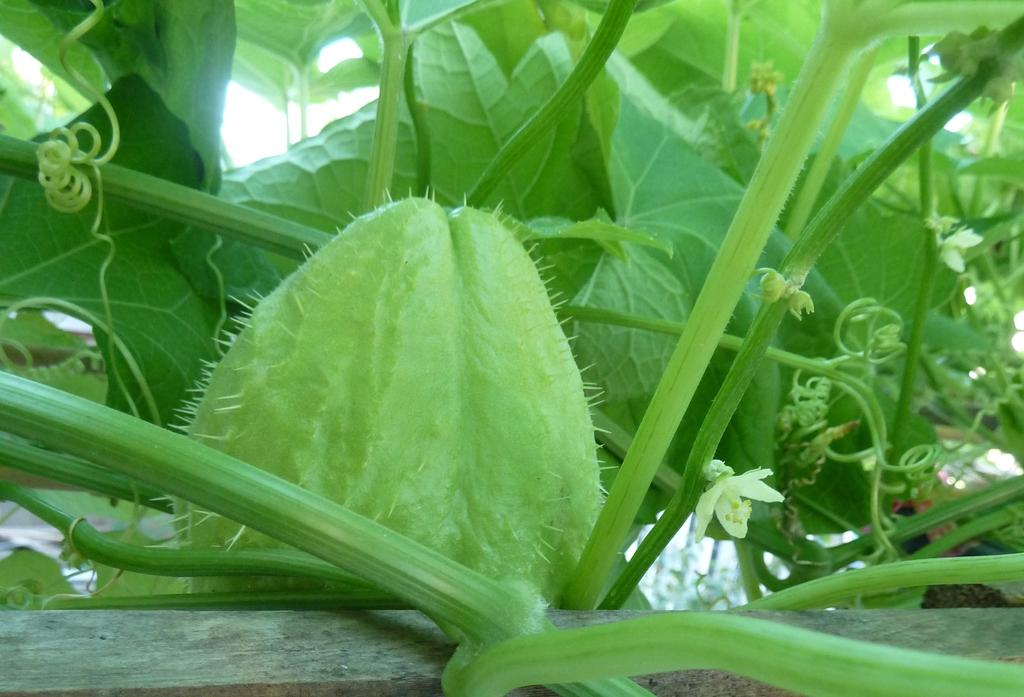What type of plant can be seen in the image? There is a plant in the image. What specific part of the plant is visible? The plant has a chayote and a flower. What can be seen in the background of the image? There is a sky visible in the background of the image. What grade of liquid is being offered by the plant in the image? There is no liquid being offered by the plant in the image; it is a plant with a chayote and a flower. 